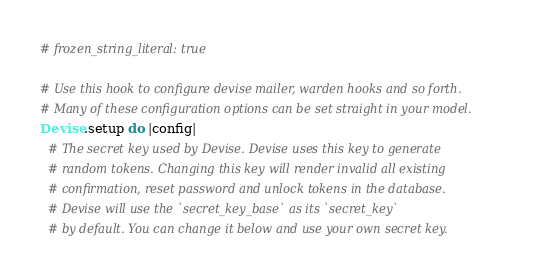<code> <loc_0><loc_0><loc_500><loc_500><_Ruby_># frozen_string_literal: true

# Use this hook to configure devise mailer, warden hooks and so forth.
# Many of these configuration options can be set straight in your model.
Devise.setup do |config|
  # The secret key used by Devise. Devise uses this key to generate
  # random tokens. Changing this key will render invalid all existing
  # confirmation, reset password and unlock tokens in the database.
  # Devise will use the `secret_key_base` as its `secret_key`
  # by default. You can change it below and use your own secret key.</code> 